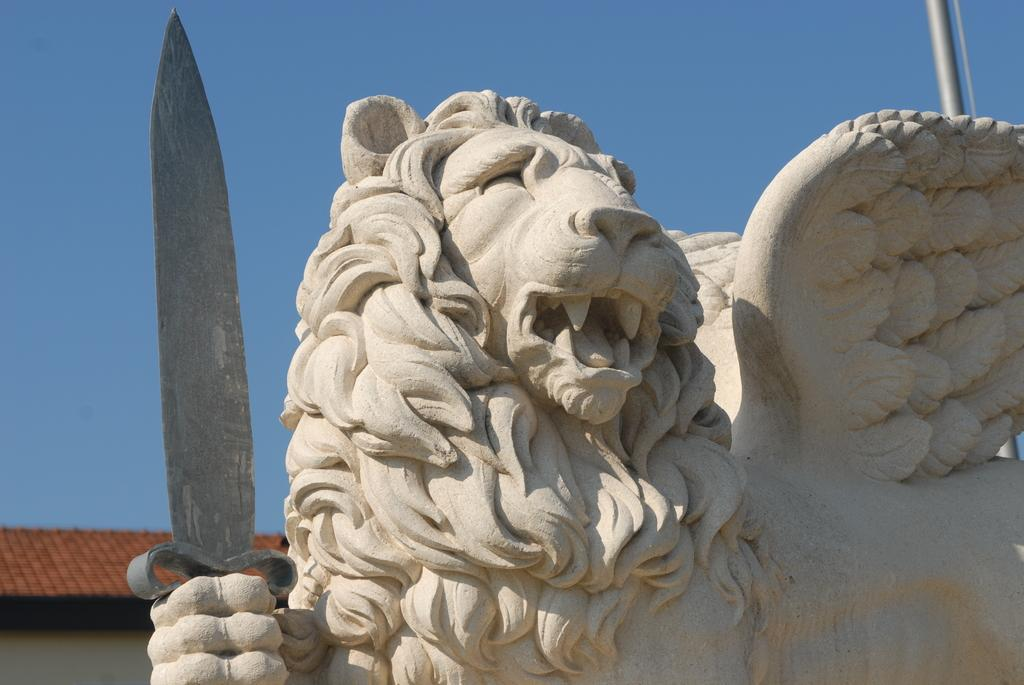What is the main subject of the image? There is a sculpture in the image. Can you describe any other elements in the image? There is a metal rod in the background of the image. What type of stocking is hanging from the sculpture in the image? There is no stocking present in the image; it only features a sculpture and a metal rod in the background. 